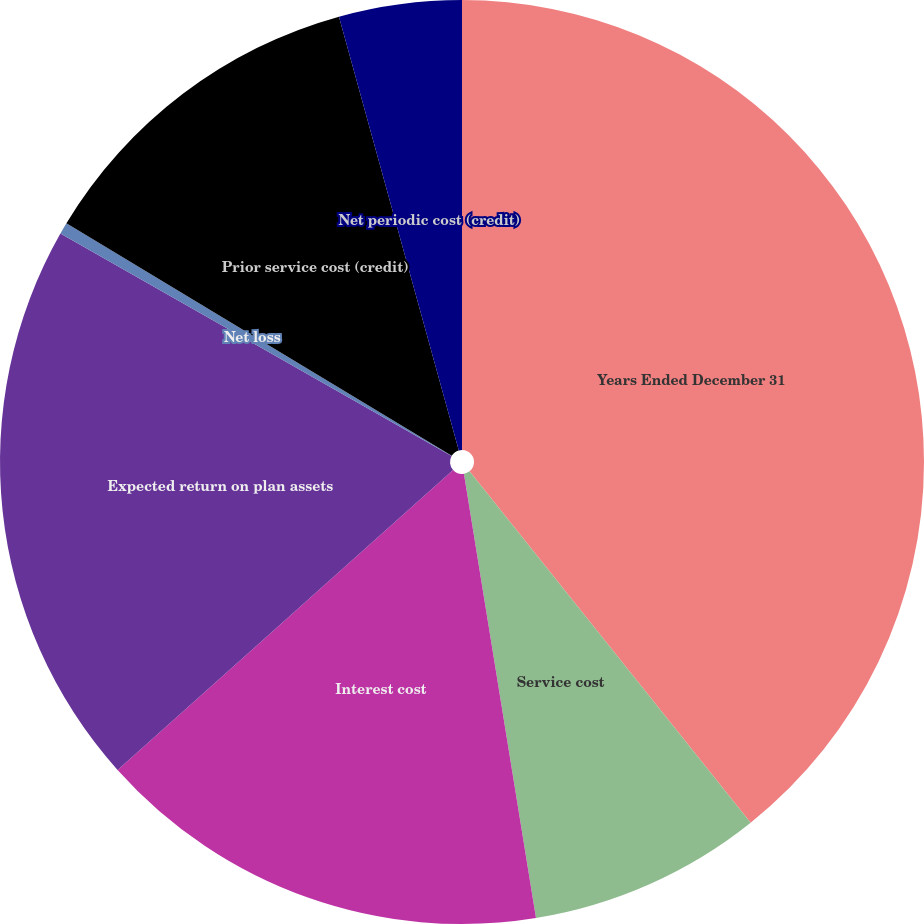<chart> <loc_0><loc_0><loc_500><loc_500><pie_chart><fcel>Years Ended December 31<fcel>Service cost<fcel>Interest cost<fcel>Expected return on plan assets<fcel>Net loss<fcel>Prior service cost (credit)<fcel>Net periodic cost (credit)<nl><fcel>39.26%<fcel>8.18%<fcel>15.95%<fcel>19.84%<fcel>0.41%<fcel>12.07%<fcel>4.29%<nl></chart> 